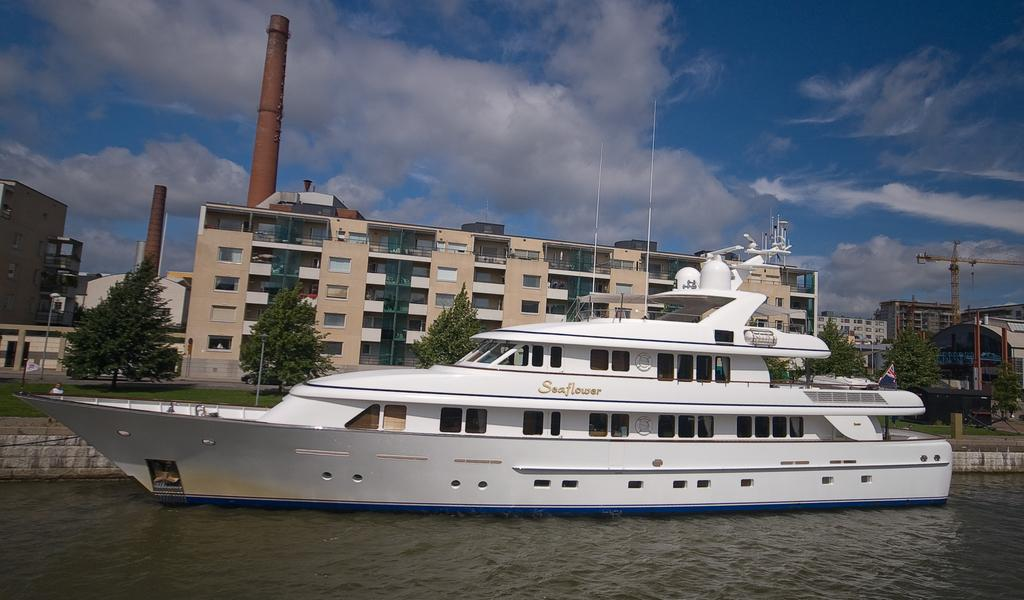What is the main subject in the image? There is a ship in the water. What can be seen in the background of the image? There is a factory in the background. What type of vegetation is in front of the factory? There are trees in front of the factory. What is visible at the top of the image? The sky is visible at the top of the image. How does the ship adjust its throat while navigating the water in the image? Ships do not have throats, and the image does not show any adjustments being made by the ship. 